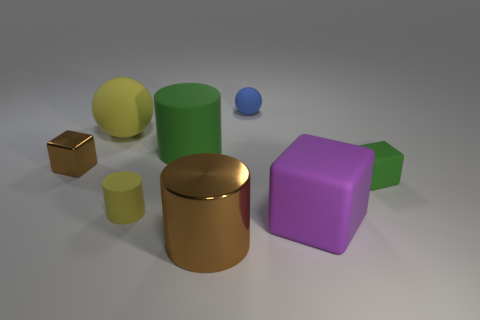What colors are the rubbery objects? The rubbery objects display a variety of colors, including yellow, green, blue, gold, and purple. 